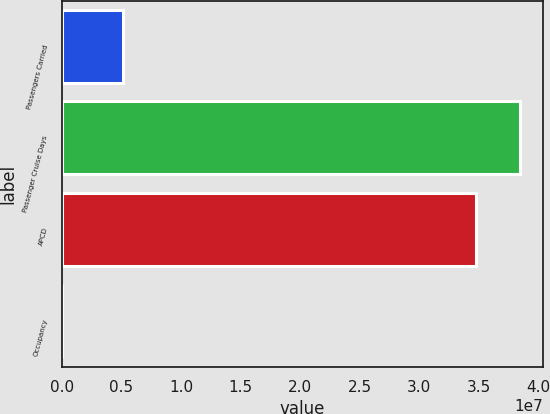Convert chart to OTSL. <chart><loc_0><loc_0><loc_500><loc_500><bar_chart><fcel>Passengers Carried<fcel>Passenger Cruise Days<fcel>APCD<fcel>Occupancy<nl><fcel>5.14995e+06<fcel>3.8445e+07<fcel>3.47739e+07<fcel>105.6<nl></chart> 